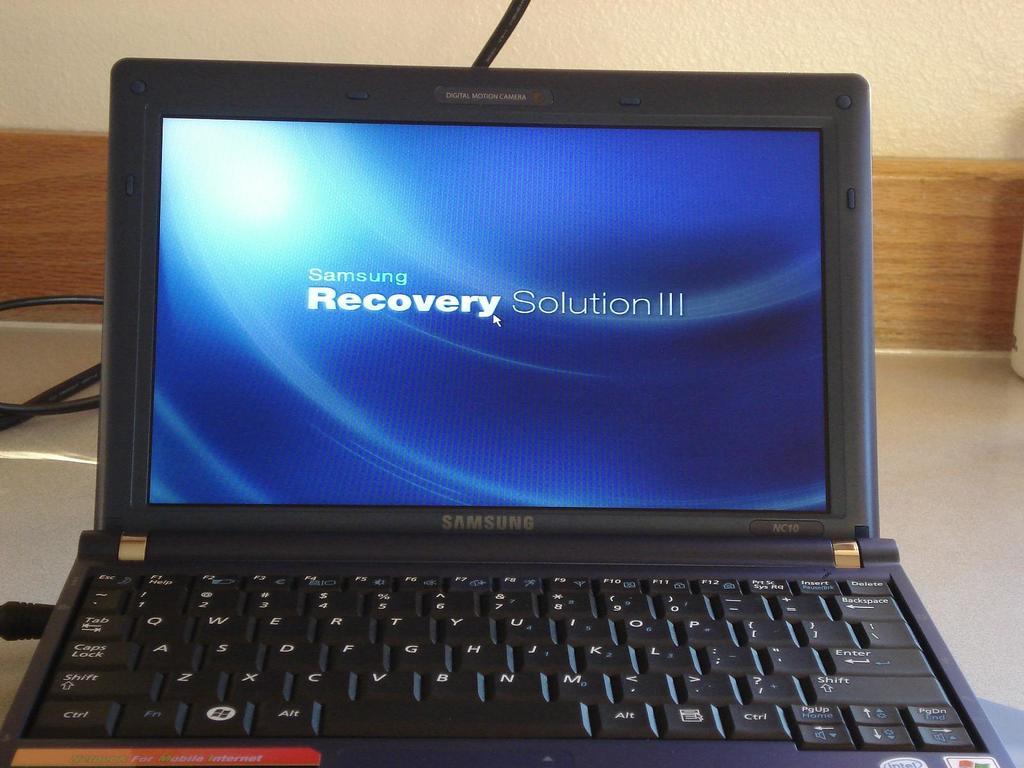What brand is this laptop?
Your answer should be very brief. Samsung. Are they working on a recovery?
Offer a terse response. Yes. 